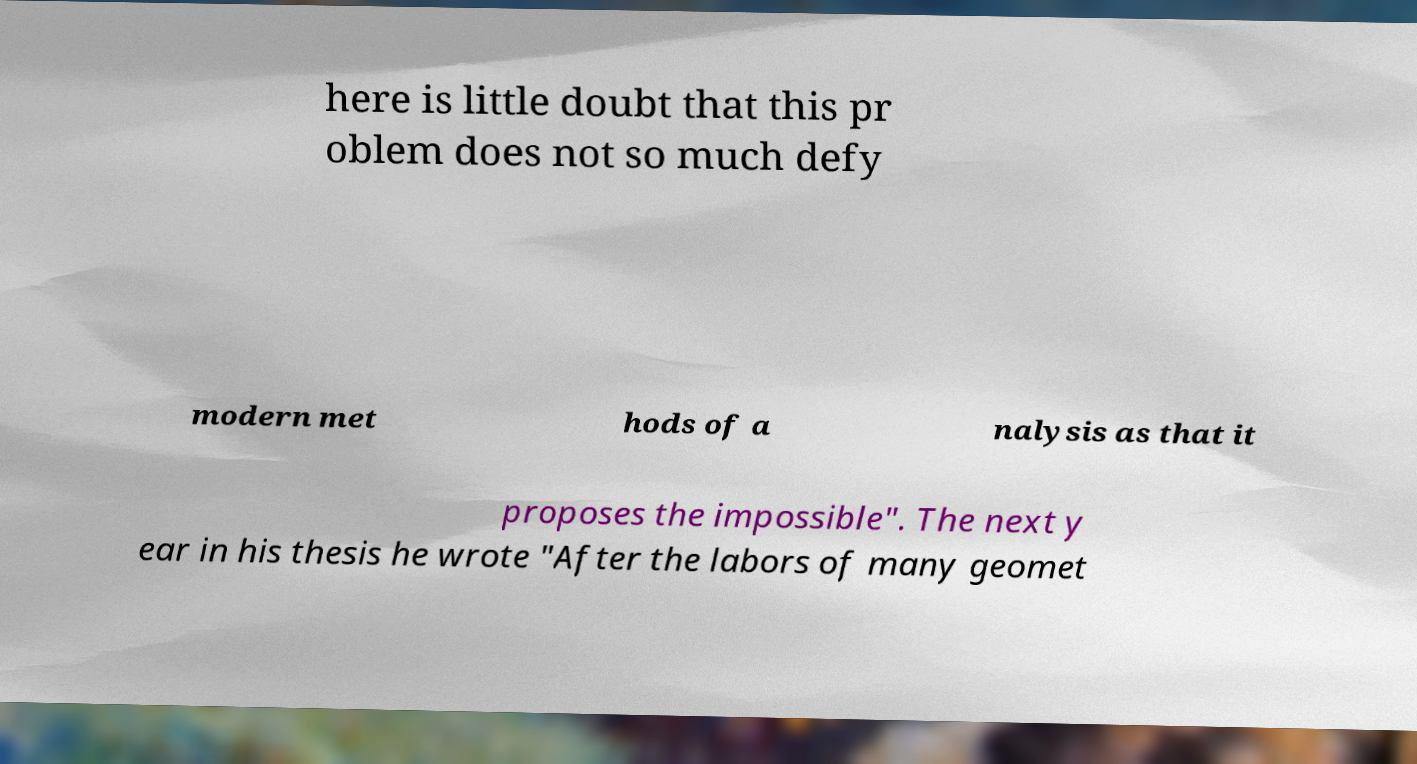Could you extract and type out the text from this image? here is little doubt that this pr oblem does not so much defy modern met hods of a nalysis as that it proposes the impossible". The next y ear in his thesis he wrote "After the labors of many geomet 